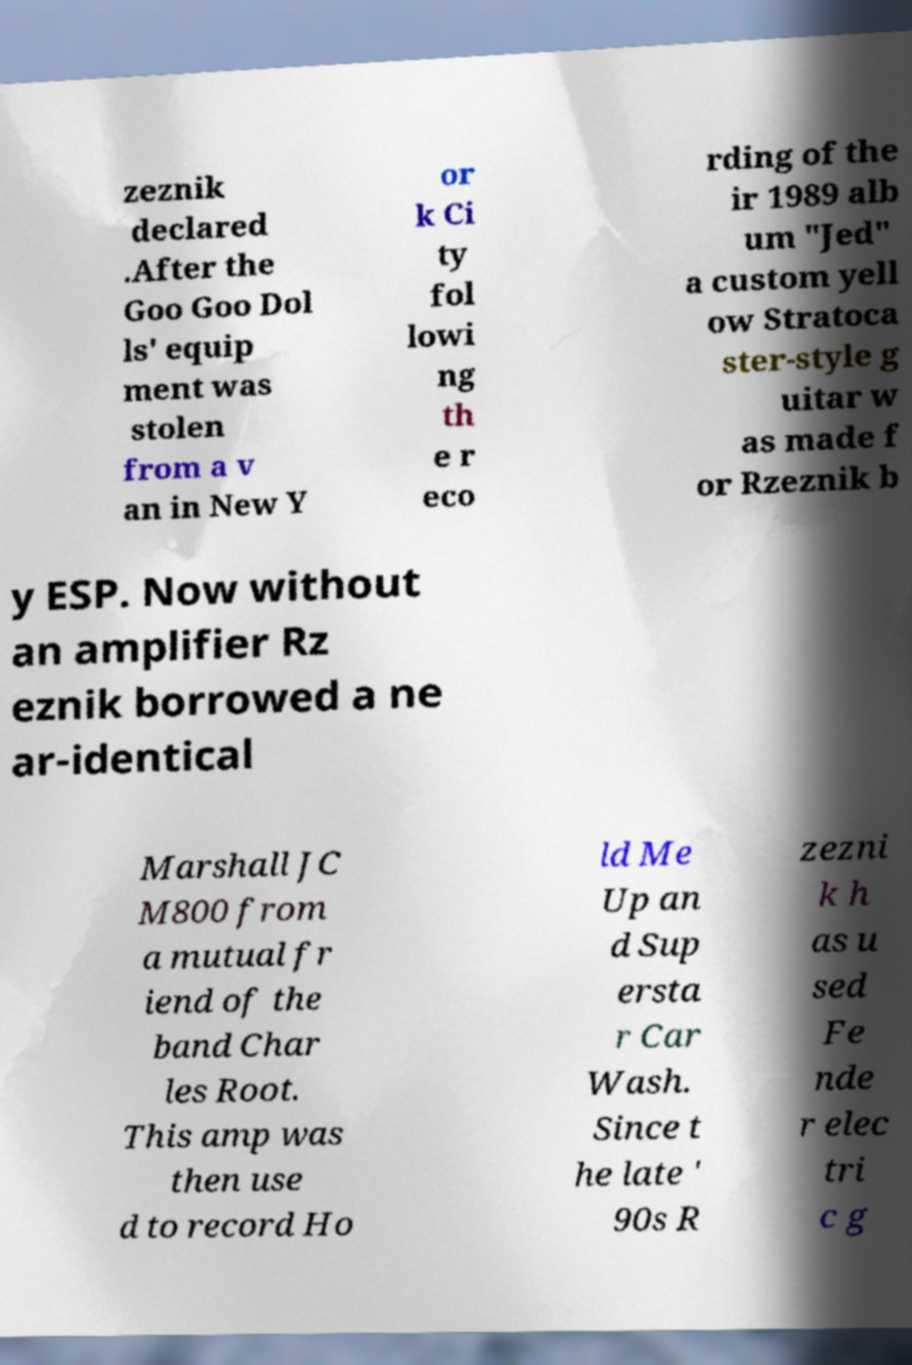Could you extract and type out the text from this image? zeznik declared .After the Goo Goo Dol ls' equip ment was stolen from a v an in New Y or k Ci ty fol lowi ng th e r eco rding of the ir 1989 alb um "Jed" a custom yell ow Stratoca ster-style g uitar w as made f or Rzeznik b y ESP. Now without an amplifier Rz eznik borrowed a ne ar-identical Marshall JC M800 from a mutual fr iend of the band Char les Root. This amp was then use d to record Ho ld Me Up an d Sup ersta r Car Wash. Since t he late ' 90s R zezni k h as u sed Fe nde r elec tri c g 